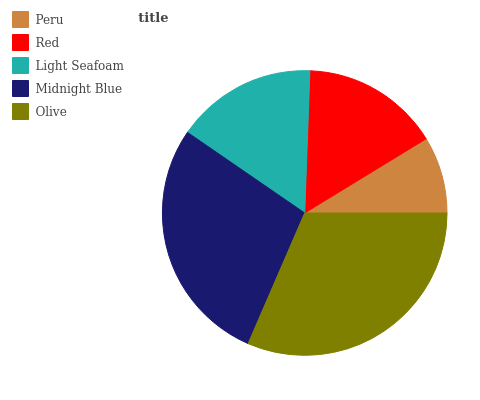Is Peru the minimum?
Answer yes or no. Yes. Is Olive the maximum?
Answer yes or no. Yes. Is Red the minimum?
Answer yes or no. No. Is Red the maximum?
Answer yes or no. No. Is Red greater than Peru?
Answer yes or no. Yes. Is Peru less than Red?
Answer yes or no. Yes. Is Peru greater than Red?
Answer yes or no. No. Is Red less than Peru?
Answer yes or no. No. Is Light Seafoam the high median?
Answer yes or no. Yes. Is Light Seafoam the low median?
Answer yes or no. Yes. Is Midnight Blue the high median?
Answer yes or no. No. Is Midnight Blue the low median?
Answer yes or no. No. 